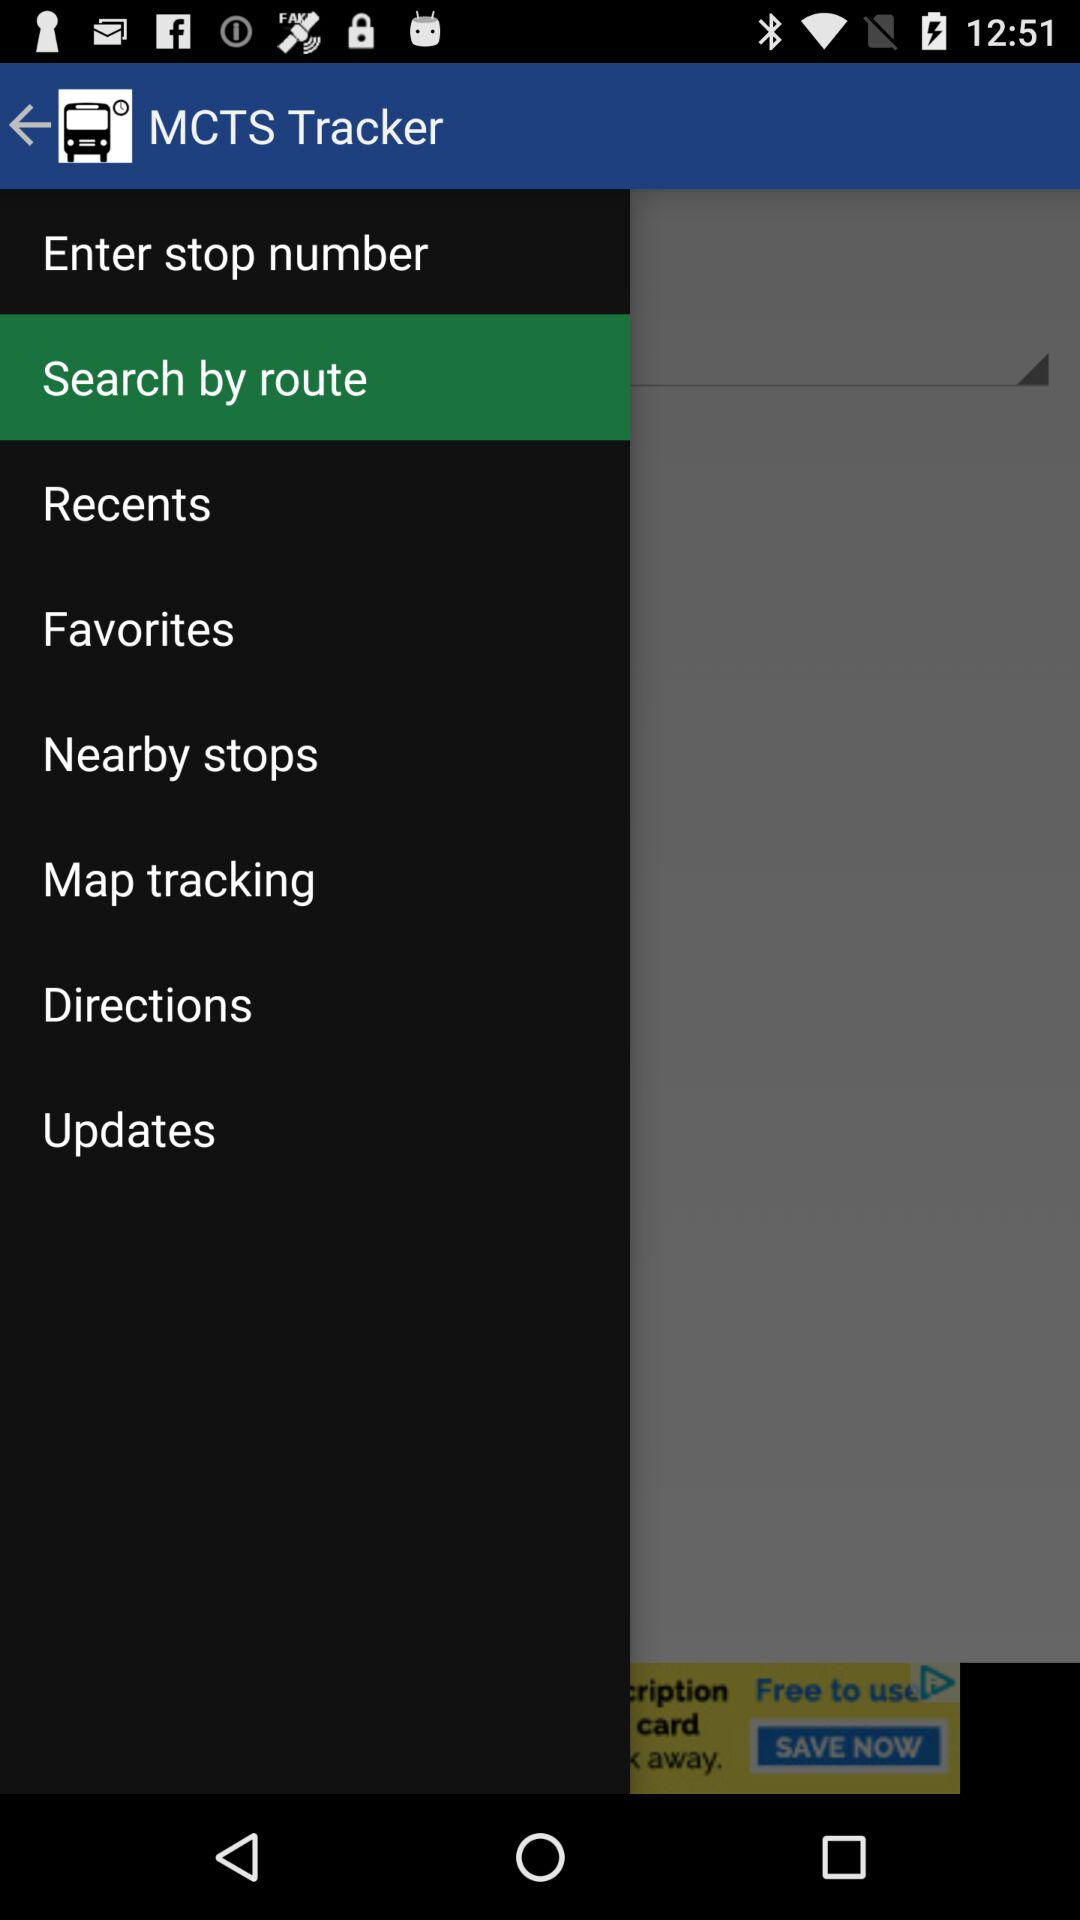Which tab is selected? The selected tab is "Search by route". 